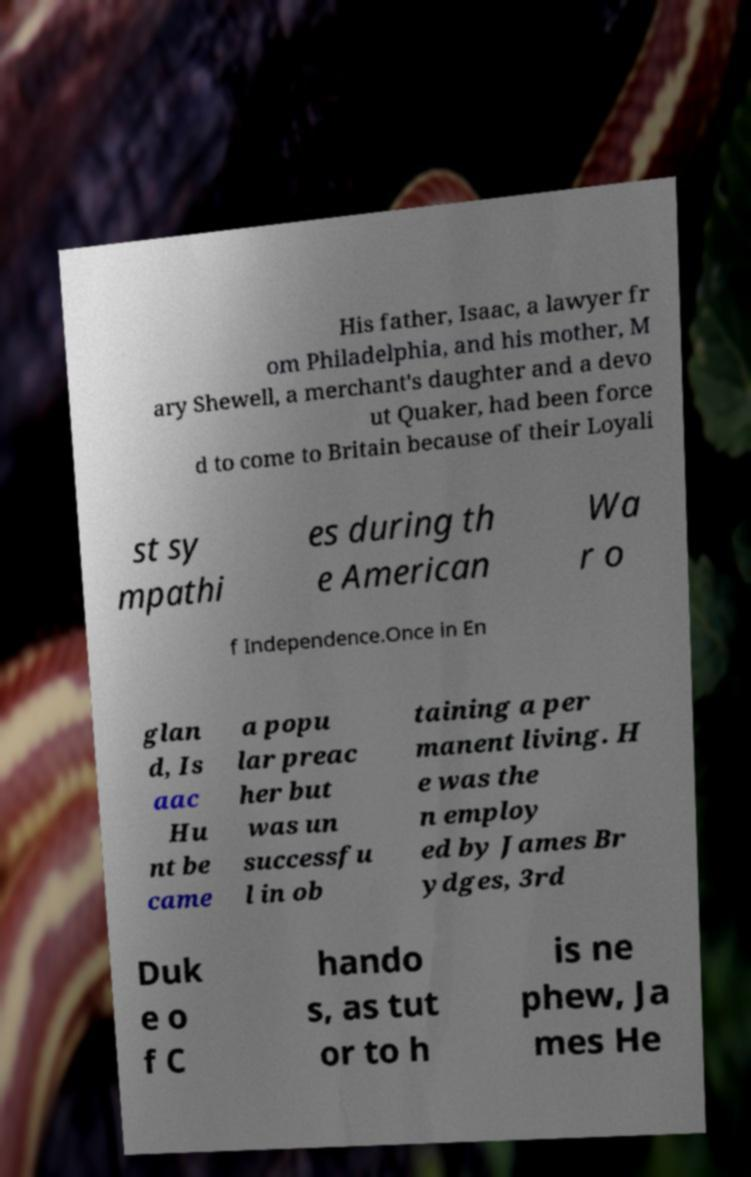Could you assist in decoding the text presented in this image and type it out clearly? His father, Isaac, a lawyer fr om Philadelphia, and his mother, M ary Shewell, a merchant's daughter and a devo ut Quaker, had been force d to come to Britain because of their Loyali st sy mpathi es during th e American Wa r o f Independence.Once in En glan d, Is aac Hu nt be came a popu lar preac her but was un successfu l in ob taining a per manent living. H e was the n employ ed by James Br ydges, 3rd Duk e o f C hando s, as tut or to h is ne phew, Ja mes He 